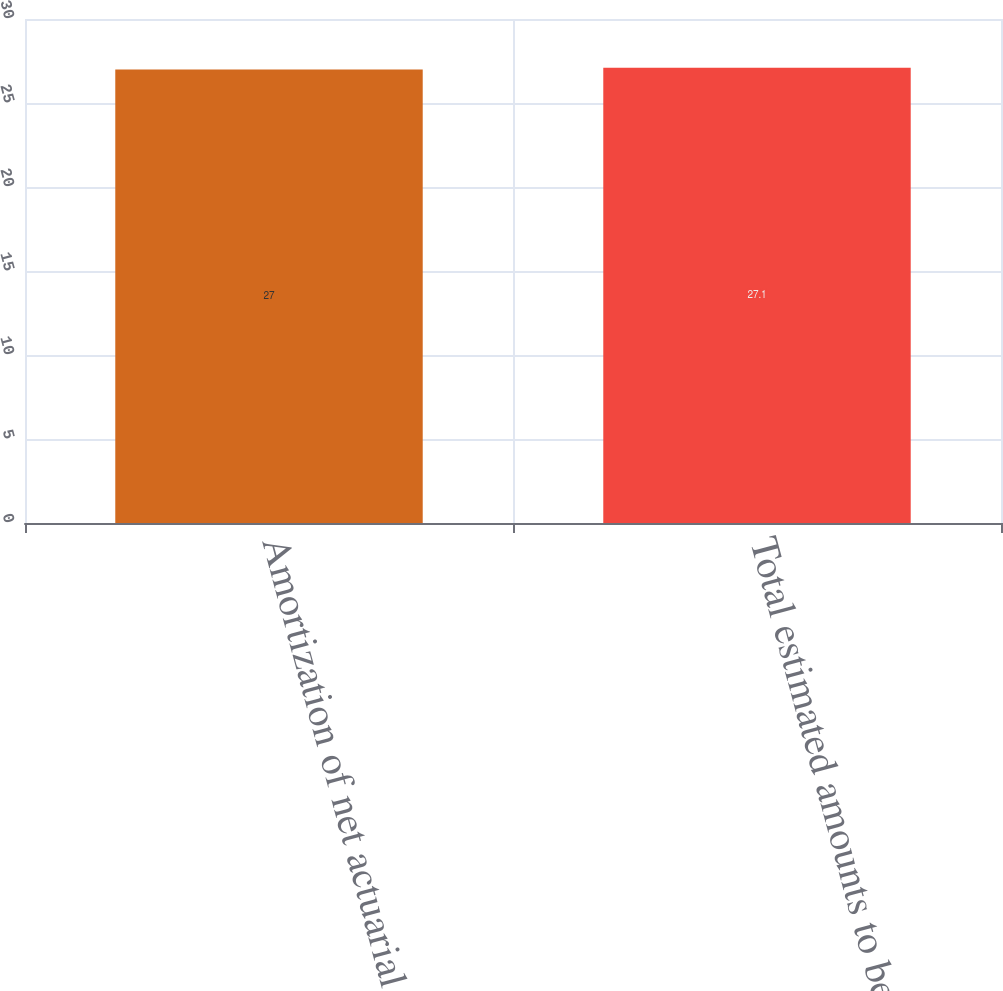<chart> <loc_0><loc_0><loc_500><loc_500><bar_chart><fcel>Amortization of net actuarial<fcel>Total estimated amounts to be<nl><fcel>27<fcel>27.1<nl></chart> 